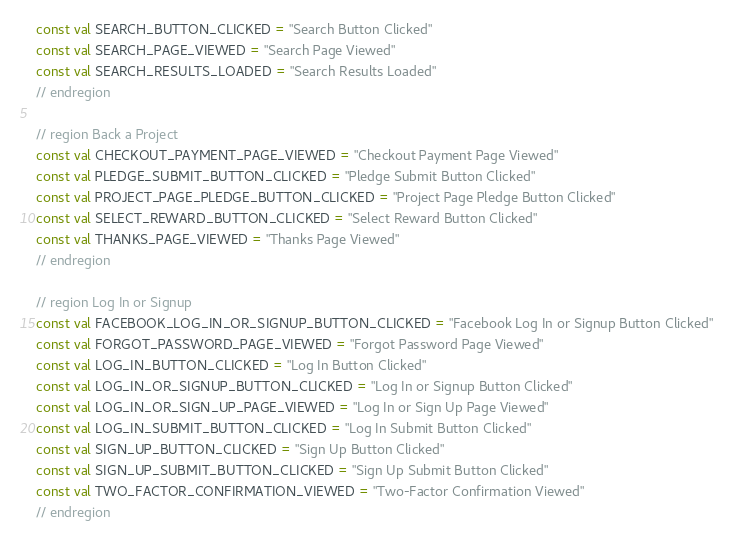<code> <loc_0><loc_0><loc_500><loc_500><_Kotlin_>const val SEARCH_BUTTON_CLICKED = "Search Button Clicked"
const val SEARCH_PAGE_VIEWED = "Search Page Viewed"
const val SEARCH_RESULTS_LOADED = "Search Results Loaded"
// endregion

// region Back a Project
const val CHECKOUT_PAYMENT_PAGE_VIEWED = "Checkout Payment Page Viewed"
const val PLEDGE_SUBMIT_BUTTON_CLICKED = "Pledge Submit Button Clicked"
const val PROJECT_PAGE_PLEDGE_BUTTON_CLICKED = "Project Page Pledge Button Clicked"
const val SELECT_REWARD_BUTTON_CLICKED = "Select Reward Button Clicked"
const val THANKS_PAGE_VIEWED = "Thanks Page Viewed"
// endregion

// region Log In or Signup
const val FACEBOOK_LOG_IN_OR_SIGNUP_BUTTON_CLICKED = "Facebook Log In or Signup Button Clicked"
const val FORGOT_PASSWORD_PAGE_VIEWED = "Forgot Password Page Viewed"
const val LOG_IN_BUTTON_CLICKED = "Log In Button Clicked"
const val LOG_IN_OR_SIGNUP_BUTTON_CLICKED = "Log In or Signup Button Clicked"
const val LOG_IN_OR_SIGN_UP_PAGE_VIEWED = "Log In or Sign Up Page Viewed"
const val LOG_IN_SUBMIT_BUTTON_CLICKED = "Log In Submit Button Clicked"
const val SIGN_UP_BUTTON_CLICKED = "Sign Up Button Clicked"
const val SIGN_UP_SUBMIT_BUTTON_CLICKED = "Sign Up Submit Button Clicked"
const val TWO_FACTOR_CONFIRMATION_VIEWED = "Two-Factor Confirmation Viewed"
// endregion
</code> 